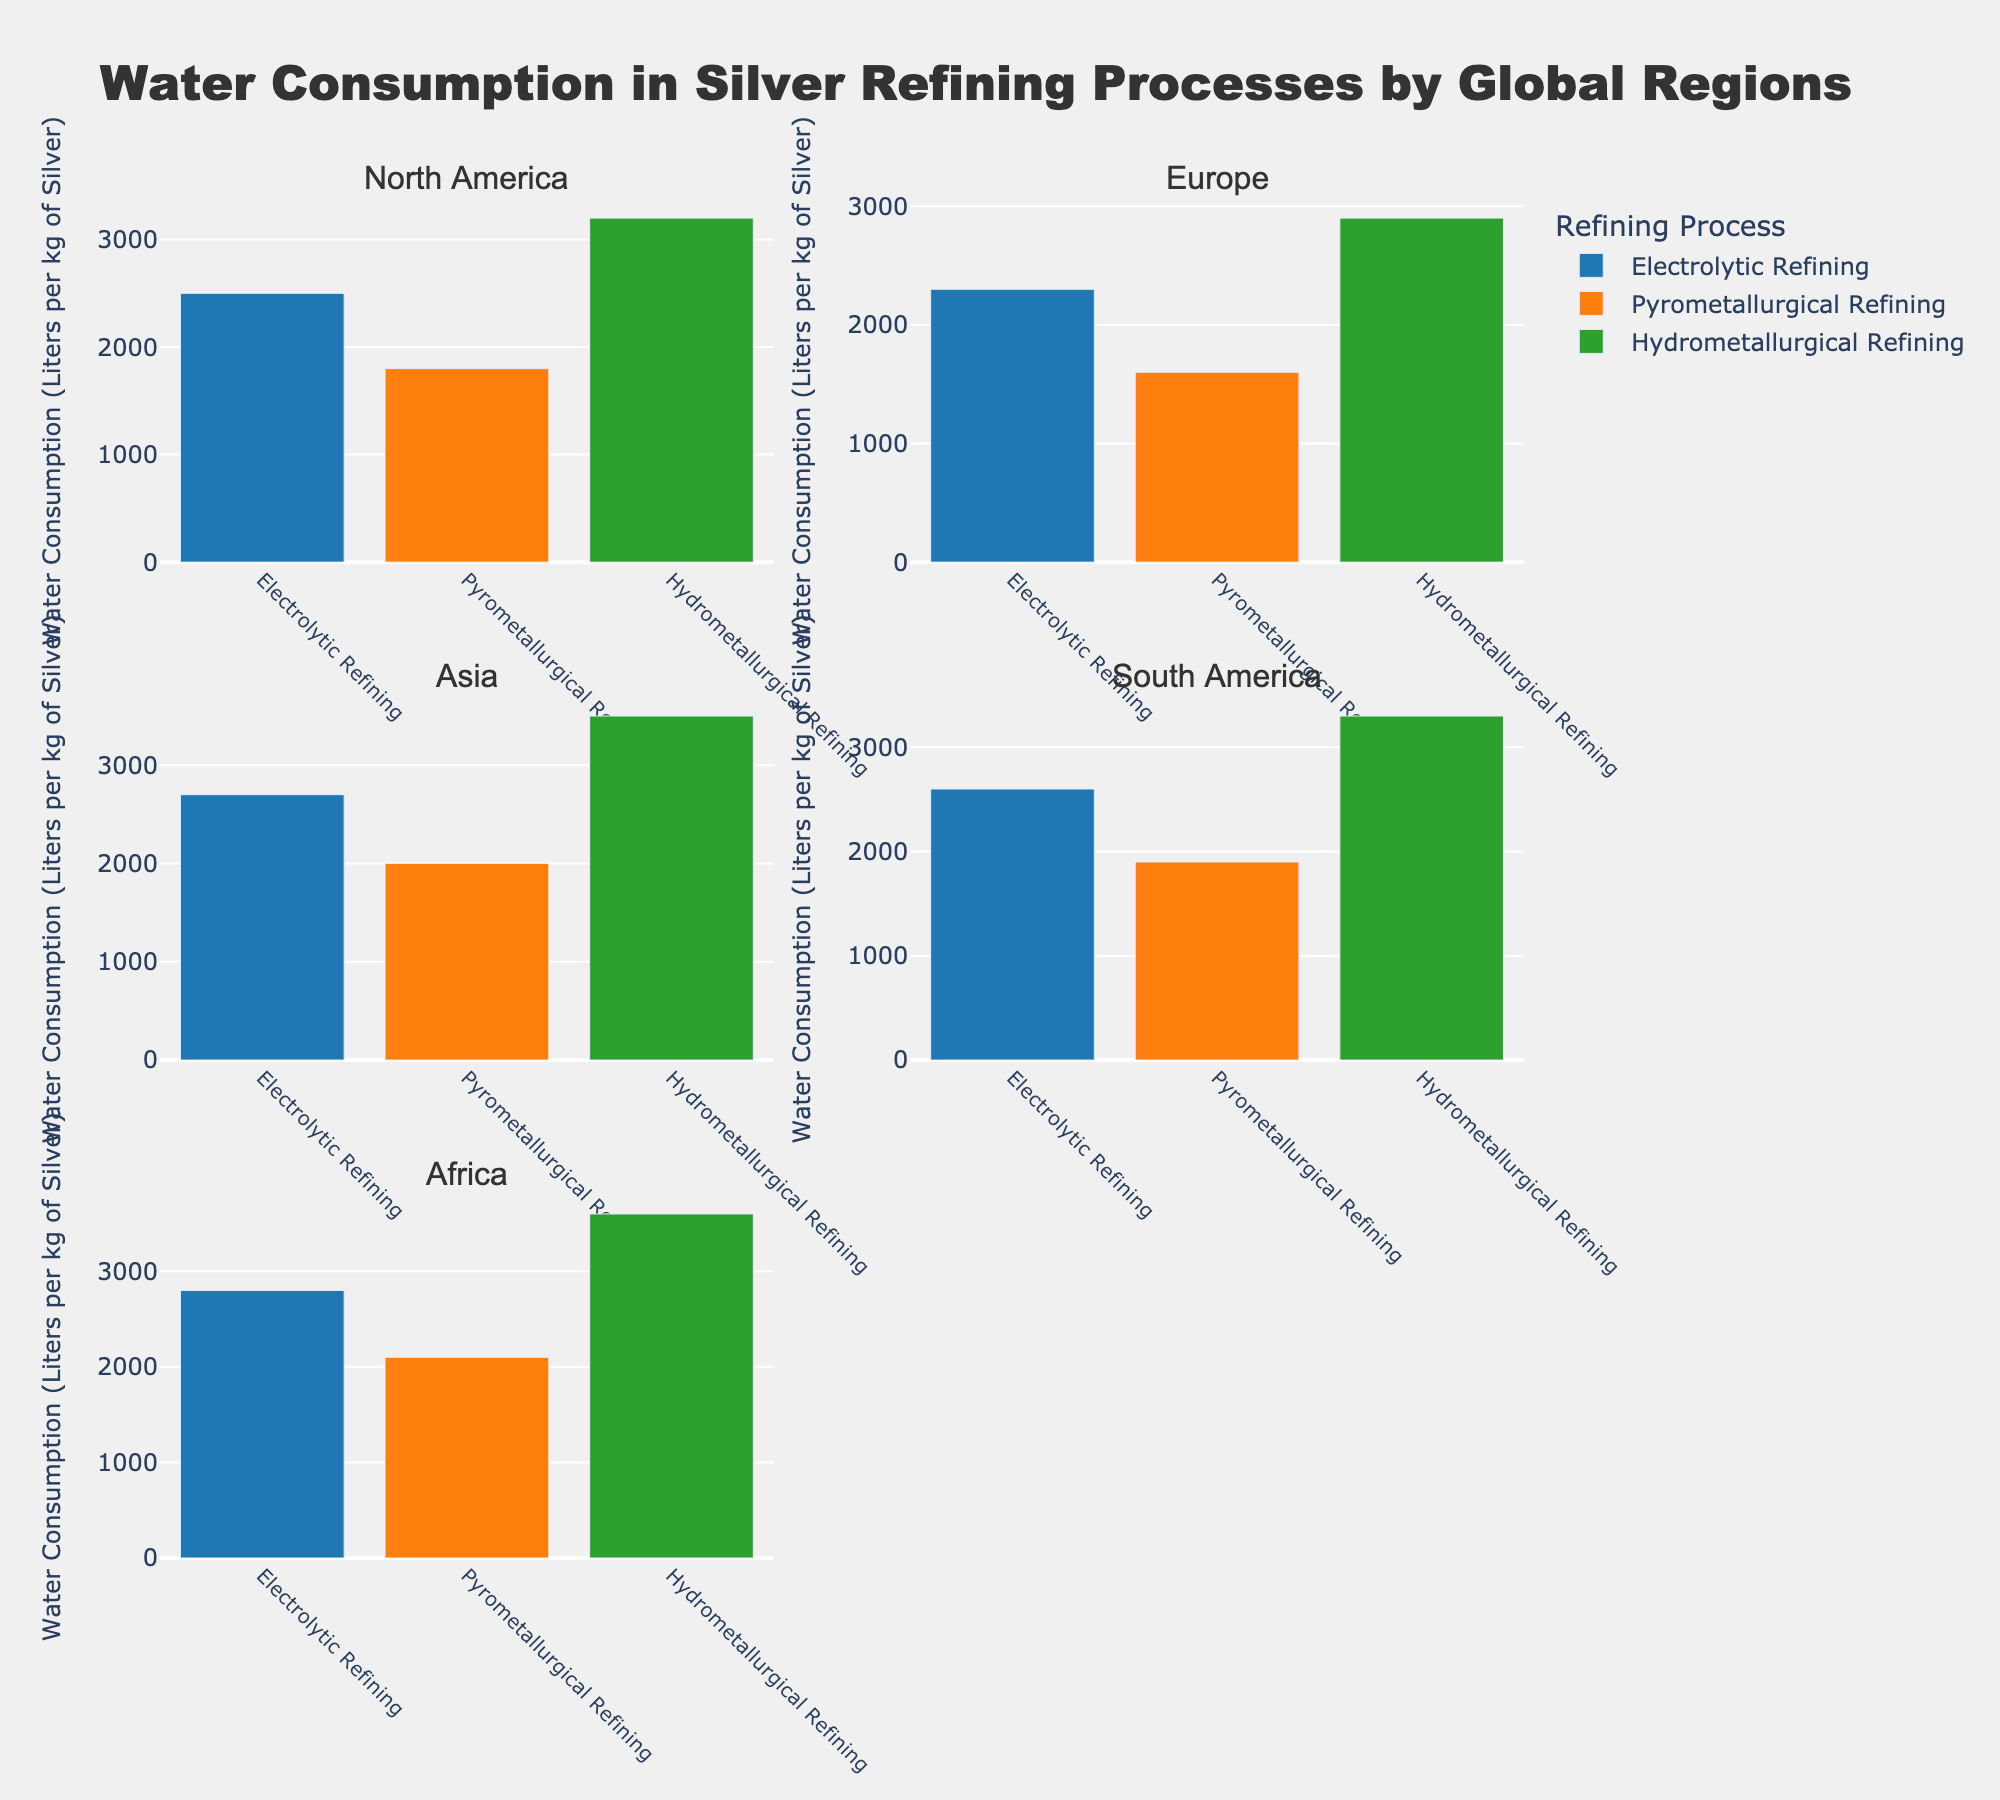Which region has the highest water consumption for Hydrometallurgical Refining? By looking at the bar heights for the Hydrometallurgical Refining process in Africa, Asia, Europe, North America, and South America subplots, Africa has the tallest bar, indicating the highest water consumption.
Answer: Africa Which refining process has the lowest water consumption in South America? In the South America subplot, the bar for Pyrometallurgical Refining is the shortest, indicating it has the lowest water consumption.
Answer: Pyrometallurgical Refining Is the water consumption for Electrolytic Refining in Asia greater than in Europe? Compare the bar heights for Electrolytic Refining in the Asia and Europe subplots. The bar in Asia is taller than the one in Europe, indicating greater water consumption.
Answer: Yes How many refining processes are depicted in the bar charts? Each subplot shows bars for three refining processes: Electrolytic Refining, Pyrometallurgical Refining, and Hydrometallurgical Refining.
Answer: 3 What is the average water consumption for Pyrometallurgical Refining across all regions? Add the water consumption values for Pyrometallurgical Refining in North America (1800), Europe (1600), Asia (2000), South America (1900), and Africa (2100), then divide by the number of regions (5). The calculation is (1800 + 1600 + 2000 + 1900 + 2100) / 5 = 9400 / 5 = 1880.
Answer: 1880 Which region has the most diverse water consumption across different refining processes? By comparing the ranges of water consumption values (the difference between the tallest and shortest bars) in each region's subplot, Africa has the widest range from 2100 (Pyrometallurgical) to 3600 (Hydrometallurgical), indicating the most diverse water consumption.
Answer: Africa What is the total water consumption for Hydrometallurgical Refining in all regions combined? Sum the water consumption values for Hydrometallurgical Refining in North America (3200), Europe (2900), Asia (3500), South America (3300), and Africa (3600). The calculation is 3200 + 2900 + 3500 + 3300 + 3600 = 16500.
Answer: 16500 Which region's Electrolytic Refining process consumes more water: North America or South America? Compare the bar heights for Electrolytic Refining in the North America and South America subplots. The bar in South America is taller than the one in North America, indicating greater water consumption.
Answer: South America 